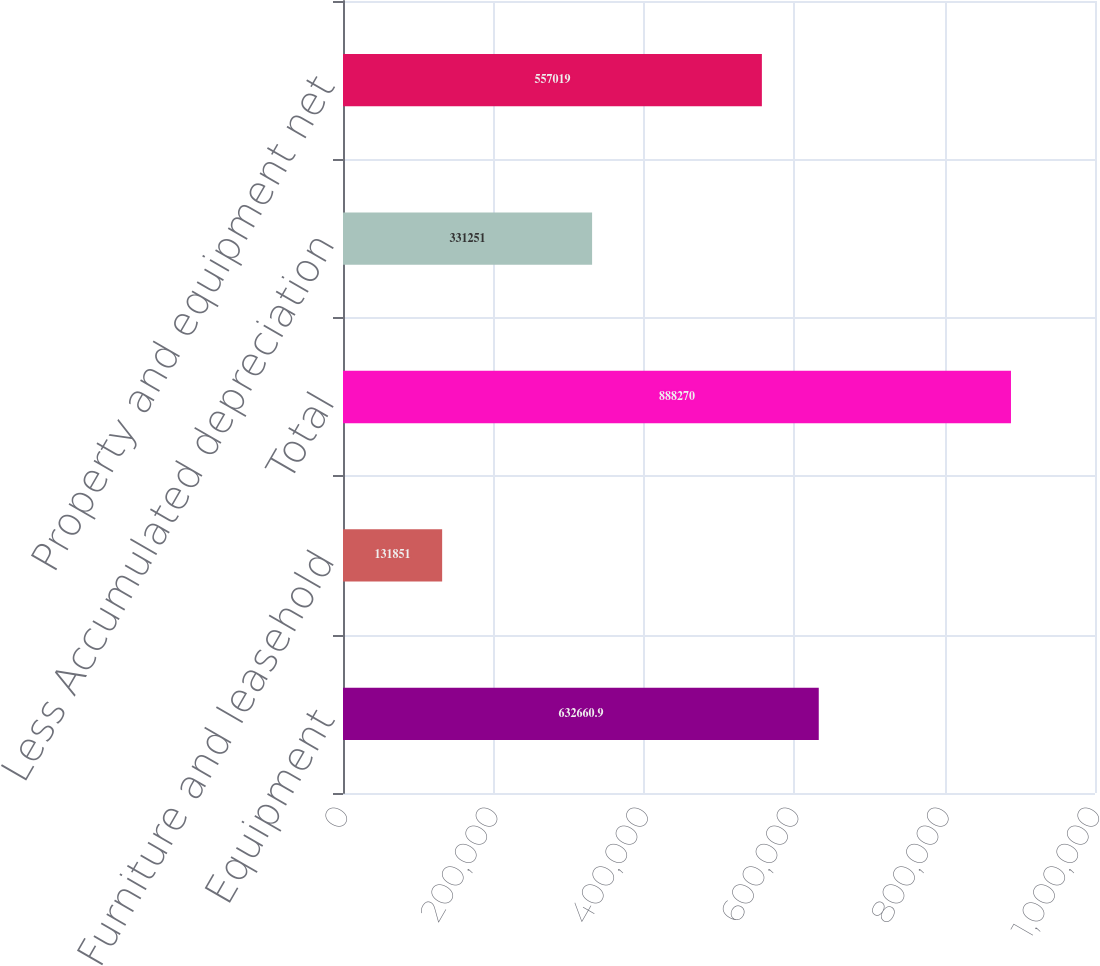<chart> <loc_0><loc_0><loc_500><loc_500><bar_chart><fcel>Equipment<fcel>Furniture and leasehold<fcel>Total<fcel>Less Accumulated depreciation<fcel>Property and equipment net<nl><fcel>632661<fcel>131851<fcel>888270<fcel>331251<fcel>557019<nl></chart> 